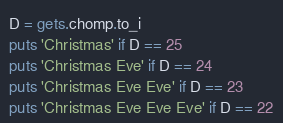<code> <loc_0><loc_0><loc_500><loc_500><_Ruby_>D = gets.chomp.to_i
puts 'Christmas' if D == 25
puts 'Christmas Eve' if D == 24
puts 'Christmas Eve Eve' if D == 23
puts 'Christmas Eve Eve Eve' if D == 22</code> 